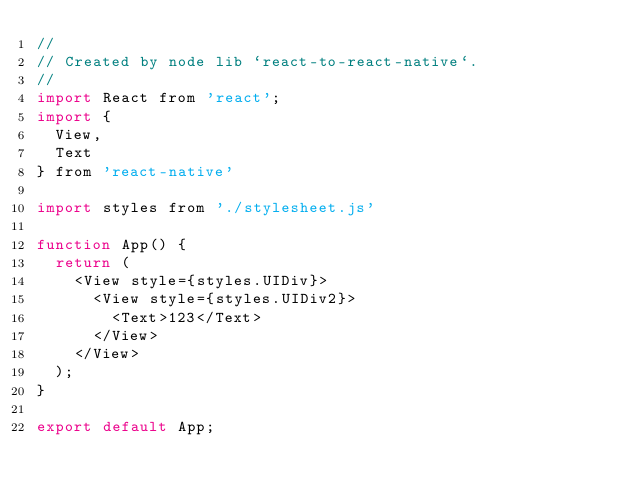<code> <loc_0><loc_0><loc_500><loc_500><_JavaScript_>//
// Created by node lib `react-to-react-native`.
// 
import React from 'react';
import {
  View,
  Text
} from 'react-native'

import styles from './stylesheet.js'

function App() {
  return (
    <View style={styles.UIDiv}>
      <View style={styles.UIDiv2}>
        <Text>123</Text>
      </View>
    </View>
  );
}

export default App;
</code> 